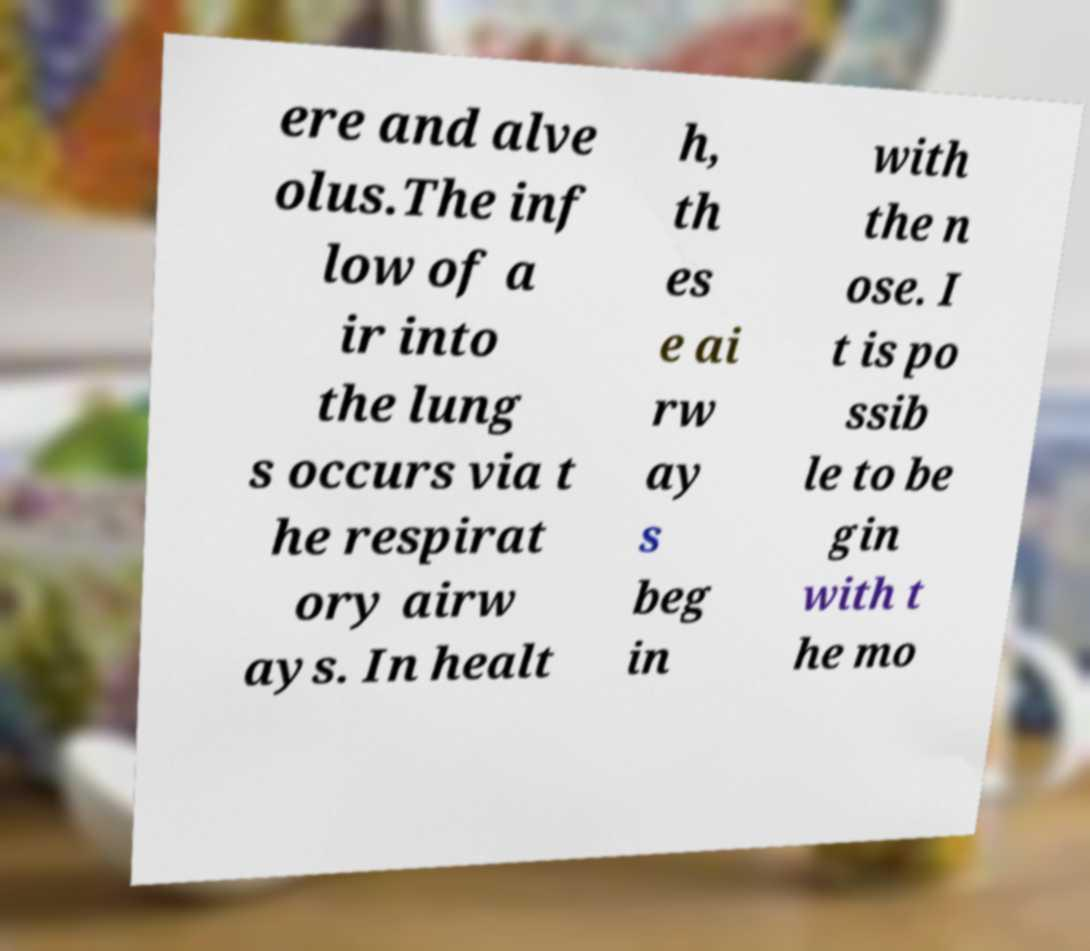Please read and relay the text visible in this image. What does it say? ere and alve olus.The inf low of a ir into the lung s occurs via t he respirat ory airw ays. In healt h, th es e ai rw ay s beg in with the n ose. I t is po ssib le to be gin with t he mo 